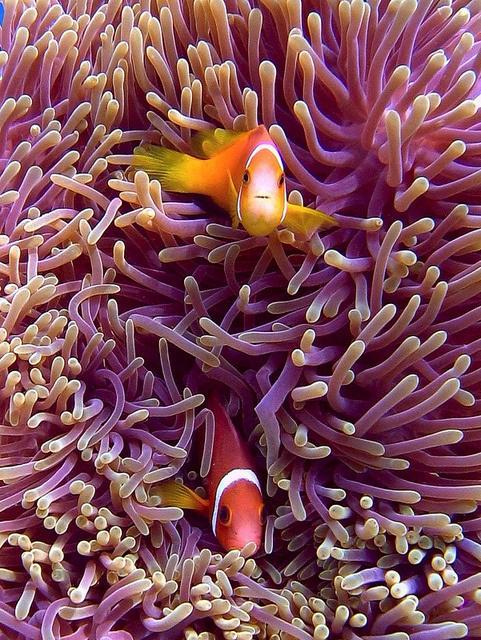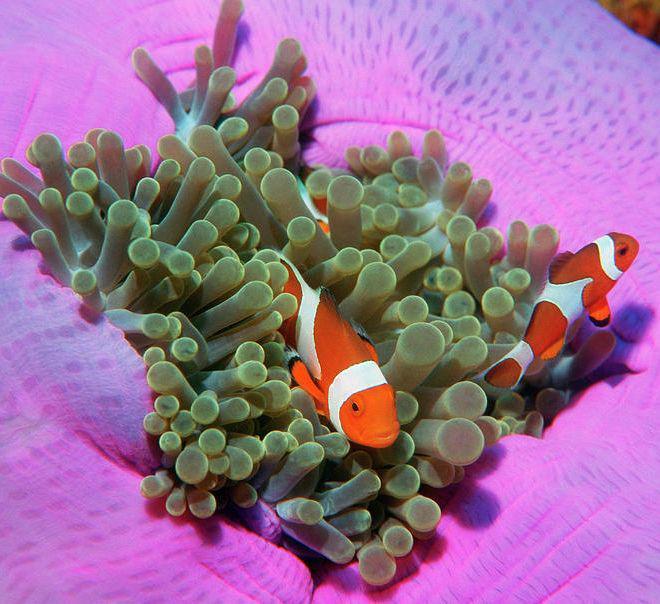The first image is the image on the left, the second image is the image on the right. Analyze the images presented: Is the assertion "The left and right image contains the same number of striped fish faces." valid? Answer yes or no. Yes. The first image is the image on the left, the second image is the image on the right. Assess this claim about the two images: "The left image contains exactly two fish, which are orange with at least one white stripe, swimming face-forward in anemone tendrils.". Correct or not? Answer yes or no. Yes. 